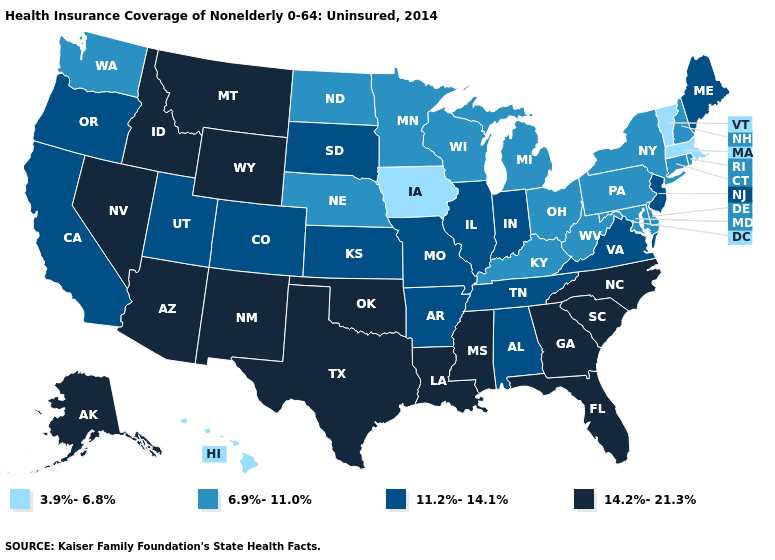What is the lowest value in states that border Louisiana?
Write a very short answer. 11.2%-14.1%. Among the states that border Arizona , does Utah have the lowest value?
Give a very brief answer. Yes. Which states hav the highest value in the Northeast?
Give a very brief answer. Maine, New Jersey. Which states have the lowest value in the South?
Quick response, please. Delaware, Kentucky, Maryland, West Virginia. Among the states that border Louisiana , which have the highest value?
Quick response, please. Mississippi, Texas. What is the value of Oregon?
Be succinct. 11.2%-14.1%. Among the states that border Virginia , which have the lowest value?
Quick response, please. Kentucky, Maryland, West Virginia. Name the states that have a value in the range 6.9%-11.0%?
Keep it brief. Connecticut, Delaware, Kentucky, Maryland, Michigan, Minnesota, Nebraska, New Hampshire, New York, North Dakota, Ohio, Pennsylvania, Rhode Island, Washington, West Virginia, Wisconsin. Does the map have missing data?
Concise answer only. No. What is the lowest value in the USA?
Write a very short answer. 3.9%-6.8%. Name the states that have a value in the range 3.9%-6.8%?
Write a very short answer. Hawaii, Iowa, Massachusetts, Vermont. How many symbols are there in the legend?
Write a very short answer. 4. What is the value of Florida?
Short answer required. 14.2%-21.3%. Among the states that border Idaho , does Nevada have the lowest value?
Write a very short answer. No. Which states have the highest value in the USA?
Short answer required. Alaska, Arizona, Florida, Georgia, Idaho, Louisiana, Mississippi, Montana, Nevada, New Mexico, North Carolina, Oklahoma, South Carolina, Texas, Wyoming. 